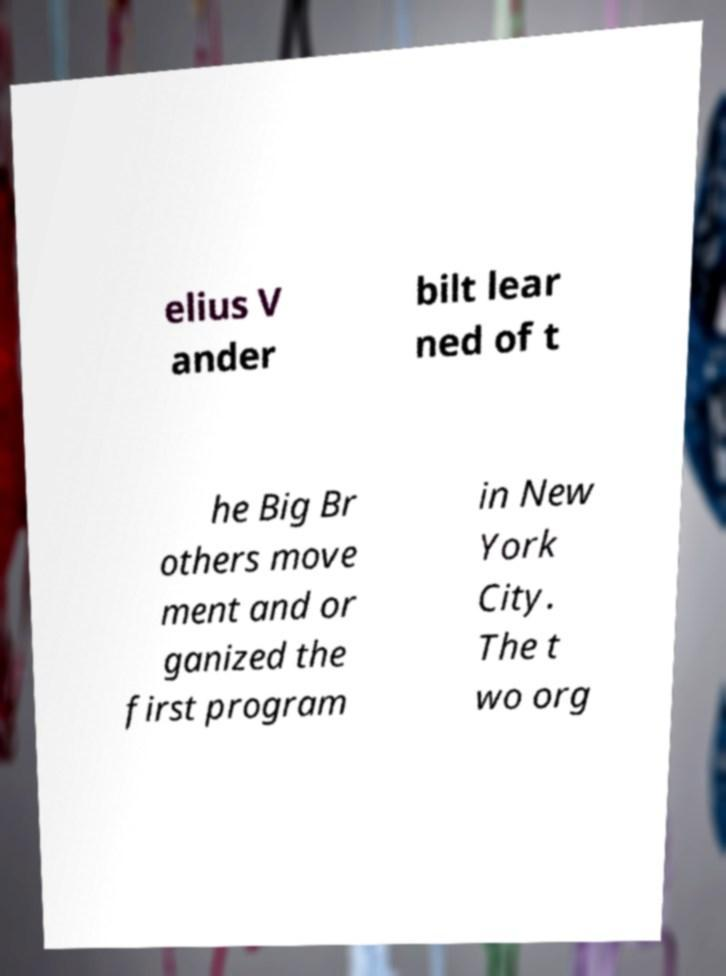I need the written content from this picture converted into text. Can you do that? elius V ander bilt lear ned of t he Big Br others move ment and or ganized the first program in New York City. The t wo org 